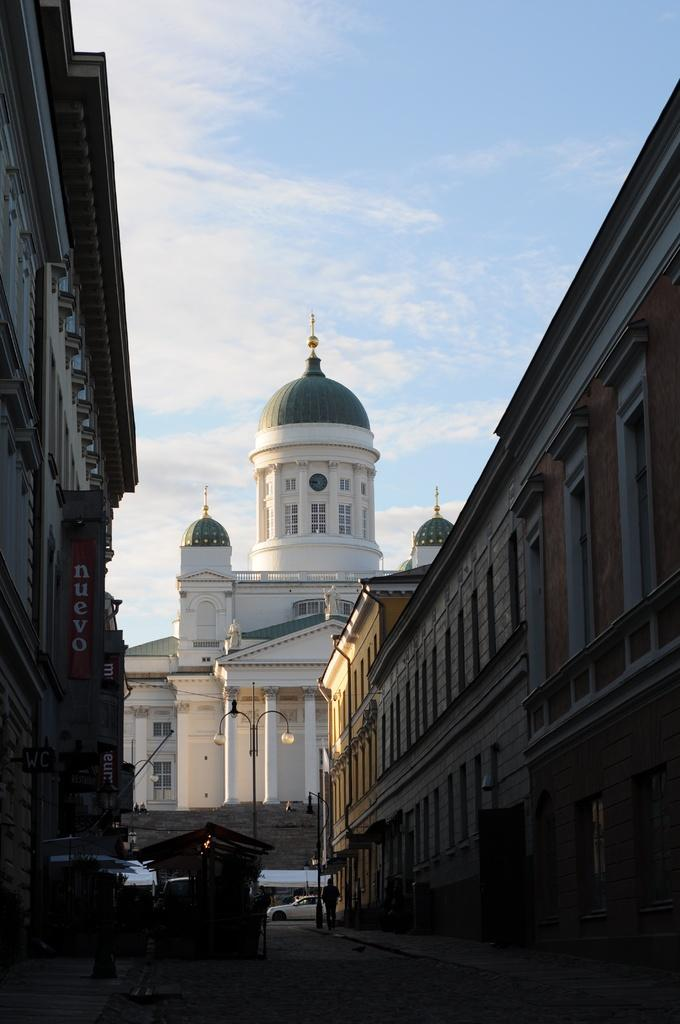What type of structures are present in the image? There are buildings in the image. What can be seen illuminating the area in the image? There are street lights in the image. What mode of transportation can be seen on the road in the image? There are vehicles on the road in the image. What is visible in the background of the image? The sky is visible in the background of the image. How many toothbrushes are visible in the image? There are no toothbrushes present in the image. Can you compare the size of the buildings in the image to the size of the vehicles? The provided facts do not include information about the size of the buildings or vehicles, so it is not possible to make a comparison. 